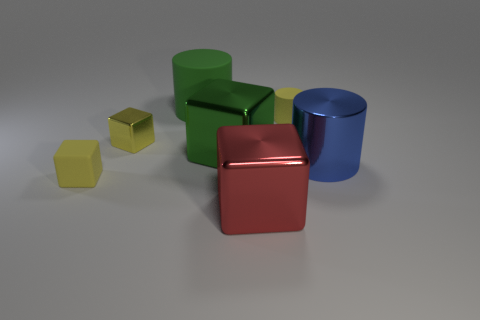What might the arrangement of these objects suggest about their purpose or context? The arrangement of the objects seems deliberate, almost resembling a still life composition which could suggest an artistic or educational purpose. The variety in shape and color could be used to teach or demonstrate concepts such as geometry, color theory, or the properties of light and how it interacts with different surfaces. 